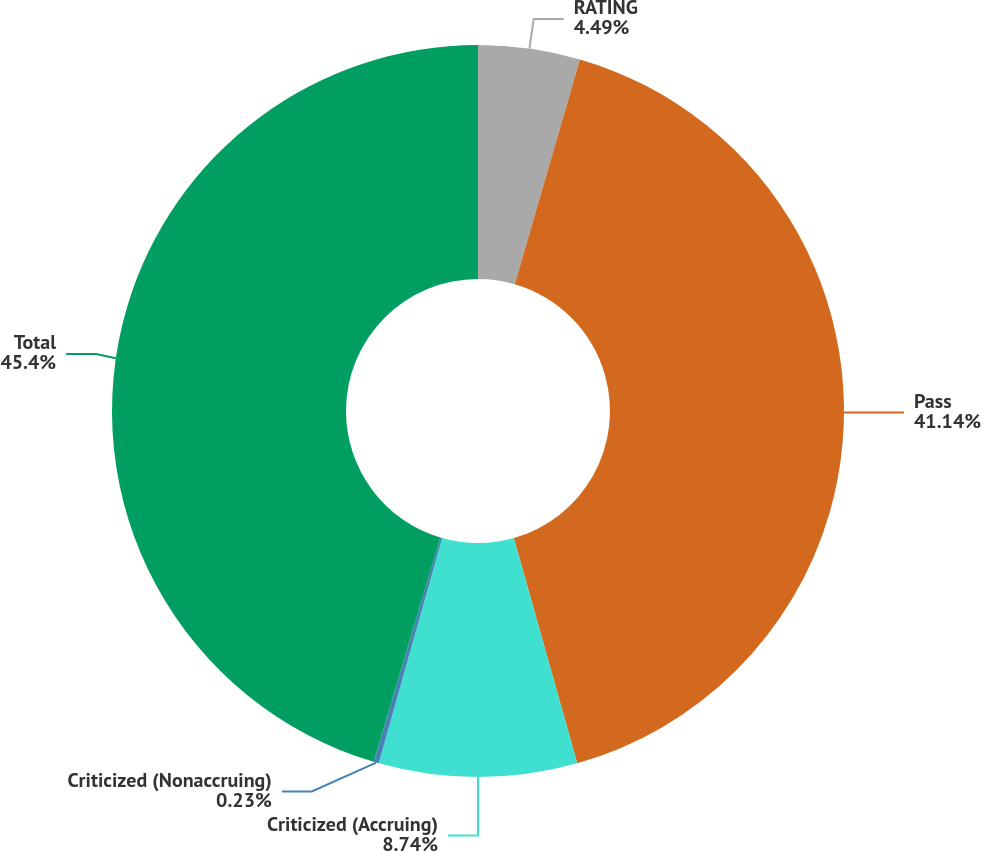Convert chart. <chart><loc_0><loc_0><loc_500><loc_500><pie_chart><fcel>RATING<fcel>Pass<fcel>Criticized (Accruing)<fcel>Criticized (Nonaccruing)<fcel>Total<nl><fcel>4.49%<fcel>41.14%<fcel>8.74%<fcel>0.23%<fcel>45.4%<nl></chart> 